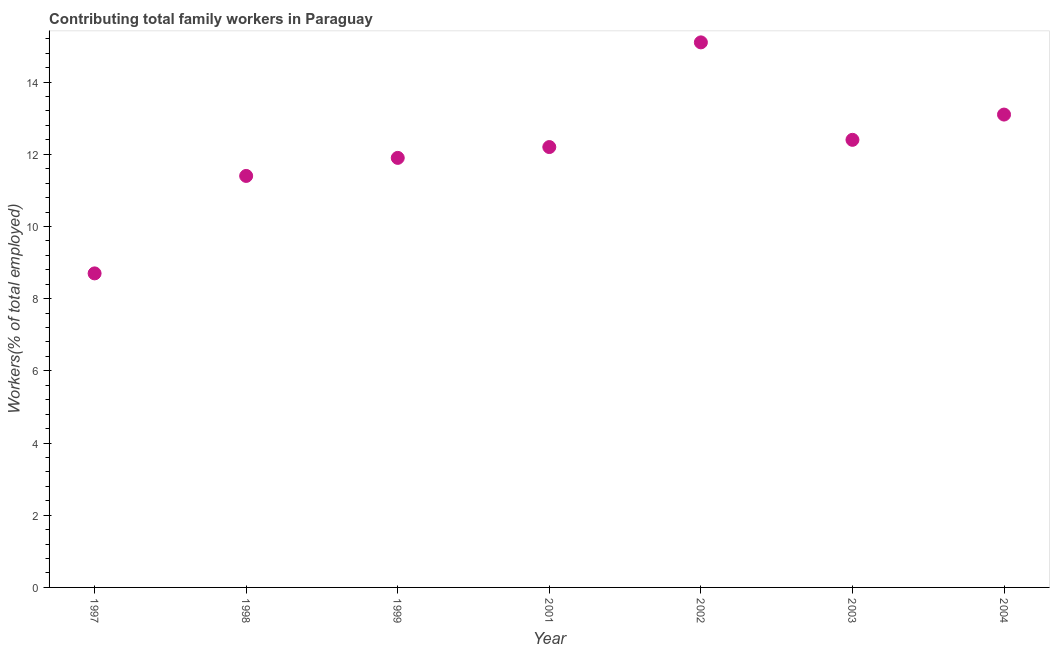What is the contributing family workers in 2002?
Make the answer very short. 15.1. Across all years, what is the maximum contributing family workers?
Give a very brief answer. 15.1. Across all years, what is the minimum contributing family workers?
Your answer should be compact. 8.7. What is the sum of the contributing family workers?
Provide a succinct answer. 84.8. What is the difference between the contributing family workers in 1997 and 1998?
Offer a terse response. -2.7. What is the average contributing family workers per year?
Provide a succinct answer. 12.11. What is the median contributing family workers?
Your answer should be very brief. 12.2. In how many years, is the contributing family workers greater than 13.2 %?
Keep it short and to the point. 1. Do a majority of the years between 1999 and 1998 (inclusive) have contributing family workers greater than 10.4 %?
Your response must be concise. No. What is the ratio of the contributing family workers in 2002 to that in 2003?
Give a very brief answer. 1.22. Is the contributing family workers in 1998 less than that in 1999?
Make the answer very short. Yes. What is the difference between the highest and the second highest contributing family workers?
Your answer should be very brief. 2. What is the difference between the highest and the lowest contributing family workers?
Your answer should be compact. 6.4. In how many years, is the contributing family workers greater than the average contributing family workers taken over all years?
Ensure brevity in your answer.  4. Does the contributing family workers monotonically increase over the years?
Provide a succinct answer. No. What is the title of the graph?
Offer a terse response. Contributing total family workers in Paraguay. What is the label or title of the X-axis?
Ensure brevity in your answer.  Year. What is the label or title of the Y-axis?
Offer a terse response. Workers(% of total employed). What is the Workers(% of total employed) in 1997?
Make the answer very short. 8.7. What is the Workers(% of total employed) in 1998?
Offer a terse response. 11.4. What is the Workers(% of total employed) in 1999?
Ensure brevity in your answer.  11.9. What is the Workers(% of total employed) in 2001?
Ensure brevity in your answer.  12.2. What is the Workers(% of total employed) in 2002?
Provide a succinct answer. 15.1. What is the Workers(% of total employed) in 2003?
Give a very brief answer. 12.4. What is the Workers(% of total employed) in 2004?
Offer a terse response. 13.1. What is the difference between the Workers(% of total employed) in 1997 and 1999?
Provide a short and direct response. -3.2. What is the difference between the Workers(% of total employed) in 1997 and 2001?
Your response must be concise. -3.5. What is the difference between the Workers(% of total employed) in 1997 and 2002?
Keep it short and to the point. -6.4. What is the difference between the Workers(% of total employed) in 1997 and 2003?
Give a very brief answer. -3.7. What is the difference between the Workers(% of total employed) in 1998 and 1999?
Give a very brief answer. -0.5. What is the difference between the Workers(% of total employed) in 1998 and 2001?
Provide a succinct answer. -0.8. What is the difference between the Workers(% of total employed) in 1998 and 2003?
Keep it short and to the point. -1. What is the difference between the Workers(% of total employed) in 1999 and 2003?
Offer a terse response. -0.5. What is the difference between the Workers(% of total employed) in 1999 and 2004?
Keep it short and to the point. -1.2. What is the difference between the Workers(% of total employed) in 2001 and 2002?
Give a very brief answer. -2.9. What is the difference between the Workers(% of total employed) in 2002 and 2003?
Offer a terse response. 2.7. What is the ratio of the Workers(% of total employed) in 1997 to that in 1998?
Offer a terse response. 0.76. What is the ratio of the Workers(% of total employed) in 1997 to that in 1999?
Your answer should be compact. 0.73. What is the ratio of the Workers(% of total employed) in 1997 to that in 2001?
Your answer should be very brief. 0.71. What is the ratio of the Workers(% of total employed) in 1997 to that in 2002?
Keep it short and to the point. 0.58. What is the ratio of the Workers(% of total employed) in 1997 to that in 2003?
Provide a succinct answer. 0.7. What is the ratio of the Workers(% of total employed) in 1997 to that in 2004?
Make the answer very short. 0.66. What is the ratio of the Workers(% of total employed) in 1998 to that in 1999?
Make the answer very short. 0.96. What is the ratio of the Workers(% of total employed) in 1998 to that in 2001?
Offer a terse response. 0.93. What is the ratio of the Workers(% of total employed) in 1998 to that in 2002?
Give a very brief answer. 0.76. What is the ratio of the Workers(% of total employed) in 1998 to that in 2003?
Ensure brevity in your answer.  0.92. What is the ratio of the Workers(% of total employed) in 1998 to that in 2004?
Make the answer very short. 0.87. What is the ratio of the Workers(% of total employed) in 1999 to that in 2002?
Keep it short and to the point. 0.79. What is the ratio of the Workers(% of total employed) in 1999 to that in 2004?
Give a very brief answer. 0.91. What is the ratio of the Workers(% of total employed) in 2001 to that in 2002?
Offer a terse response. 0.81. What is the ratio of the Workers(% of total employed) in 2001 to that in 2003?
Your answer should be compact. 0.98. What is the ratio of the Workers(% of total employed) in 2001 to that in 2004?
Your answer should be very brief. 0.93. What is the ratio of the Workers(% of total employed) in 2002 to that in 2003?
Your answer should be compact. 1.22. What is the ratio of the Workers(% of total employed) in 2002 to that in 2004?
Provide a succinct answer. 1.15. What is the ratio of the Workers(% of total employed) in 2003 to that in 2004?
Make the answer very short. 0.95. 